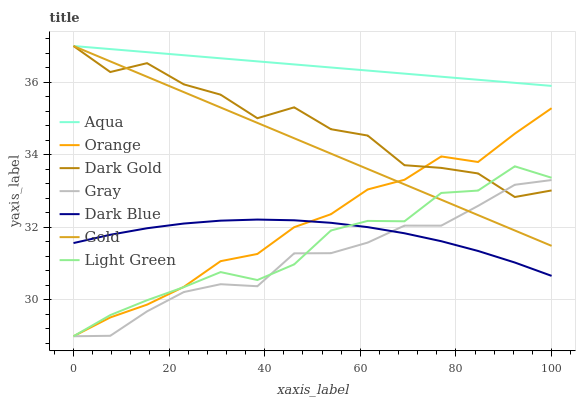Does Gray have the minimum area under the curve?
Answer yes or no. Yes. Does Aqua have the maximum area under the curve?
Answer yes or no. Yes. Does Gold have the minimum area under the curve?
Answer yes or no. No. Does Gold have the maximum area under the curve?
Answer yes or no. No. Is Aqua the smoothest?
Answer yes or no. Yes. Is Dark Gold the roughest?
Answer yes or no. Yes. Is Gold the smoothest?
Answer yes or no. No. Is Gold the roughest?
Answer yes or no. No. Does Gray have the lowest value?
Answer yes or no. Yes. Does Gold have the lowest value?
Answer yes or no. No. Does Aqua have the highest value?
Answer yes or no. Yes. Does Dark Blue have the highest value?
Answer yes or no. No. Is Light Green less than Aqua?
Answer yes or no. Yes. Is Gold greater than Dark Blue?
Answer yes or no. Yes. Does Gold intersect Gray?
Answer yes or no. Yes. Is Gold less than Gray?
Answer yes or no. No. Is Gold greater than Gray?
Answer yes or no. No. Does Light Green intersect Aqua?
Answer yes or no. No. 